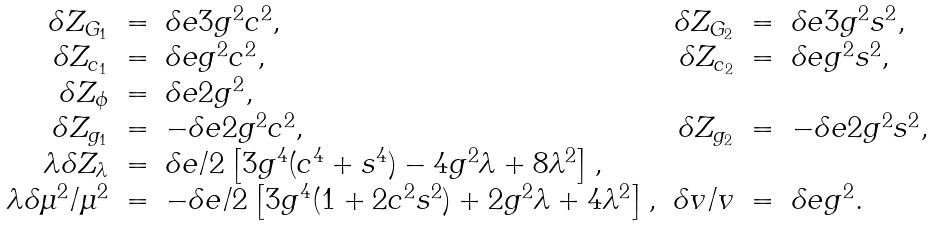Convert formula to latex. <formula><loc_0><loc_0><loc_500><loc_500>\begin{array} { r c l r c l } \delta Z _ { G _ { 1 } } & = & \delta e 3 g ^ { 2 } c ^ { 2 } , & \delta Z _ { G _ { 2 } } & = & \delta e 3 g ^ { 2 } s ^ { 2 } , \\ \delta Z _ { c _ { 1 } } & = & \delta e g ^ { 2 } c ^ { 2 } , & \delta Z _ { c _ { 2 } } & = & \delta e g ^ { 2 } s ^ { 2 } , \\ \delta Z _ { \phi } & = & \delta e 2 g ^ { 2 } , & & & \\ \delta Z _ { g _ { 1 } } & = & - \delta e 2 g ^ { 2 } c ^ { 2 } , & \delta Z _ { g _ { 2 } } & = & - \delta e 2 g ^ { 2 } s ^ { 2 } , \\ \lambda \delta Z _ { \lambda } & = & \delta e / 2 \left [ 3 g ^ { 4 } ( c ^ { 4 } + s ^ { 4 } ) - 4 g ^ { 2 } \lambda + 8 \lambda ^ { 2 } \right ] , & & & \\ \lambda \delta \mu ^ { 2 } / \mu ^ { 2 } & = & - \delta e / 2 \left [ 3 g ^ { 4 } ( 1 + 2 c ^ { 2 } s ^ { 2 } ) + 2 g ^ { 2 } \lambda + 4 \lambda ^ { 2 } \right ] , & \delta v / v & = & \delta e g ^ { 2 } . \end{array}</formula> 